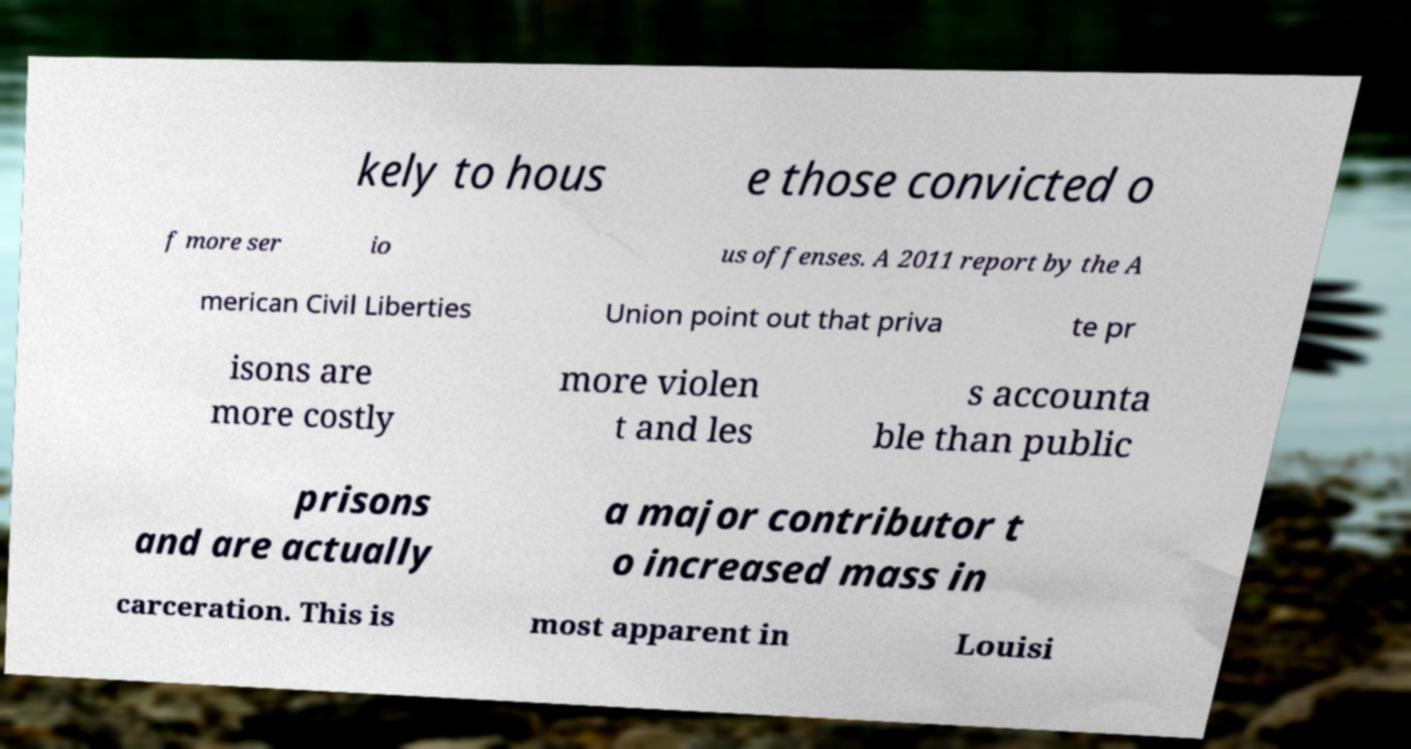Can you accurately transcribe the text from the provided image for me? kely to hous e those convicted o f more ser io us offenses. A 2011 report by the A merican Civil Liberties Union point out that priva te pr isons are more costly more violen t and les s accounta ble than public prisons and are actually a major contributor t o increased mass in carceration. This is most apparent in Louisi 